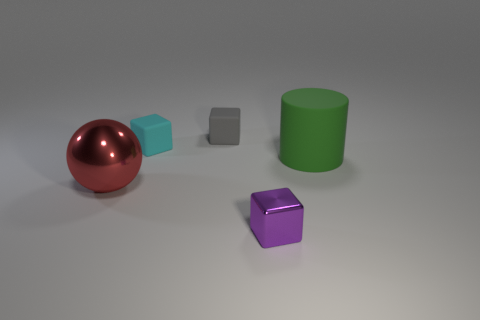Is there anything else that is the same shape as the big shiny thing?
Make the answer very short. No. There is a matte thing to the right of the cube in front of the large red metallic sphere; what is its shape?
Give a very brief answer. Cylinder. What is the size of the green cylinder to the right of the shiny object left of the matte object left of the gray block?
Offer a terse response. Large. Does the tiny gray matte object have the same shape as the small thing in front of the red metallic sphere?
Give a very brief answer. Yes. There is a cube that is the same material as the red sphere; what size is it?
Offer a terse response. Small. Are there any other things of the same color as the big matte object?
Your response must be concise. No. There is a large thing that is on the left side of the small thing in front of the large thing that is to the left of the big cylinder; what is its material?
Your answer should be very brief. Metal. What number of shiny things are either gray things or small purple cubes?
Offer a very short reply. 1. How many objects are big green rubber cylinders or tiny blocks behind the green thing?
Your answer should be compact. 3. There is a metal thing that is in front of the red metallic object; does it have the same size as the gray object?
Provide a succinct answer. Yes. 